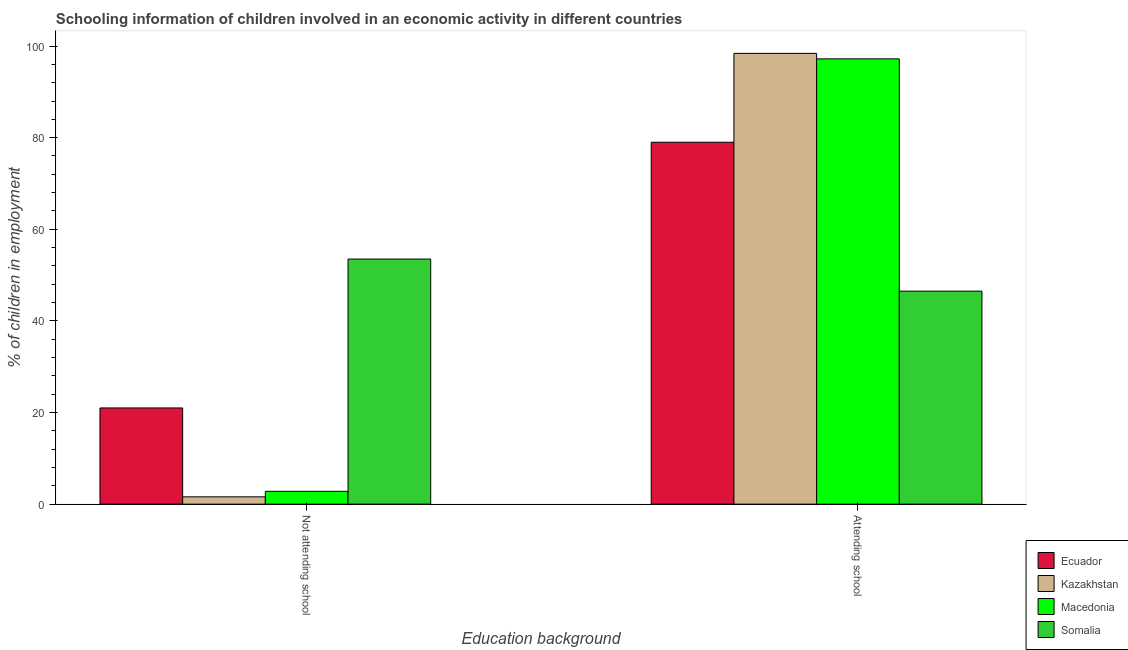Are the number of bars per tick equal to the number of legend labels?
Your response must be concise. Yes. How many bars are there on the 2nd tick from the left?
Keep it short and to the point. 4. How many bars are there on the 1st tick from the right?
Keep it short and to the point. 4. What is the label of the 2nd group of bars from the left?
Make the answer very short. Attending school. What is the percentage of employed children who are attending school in Ecuador?
Provide a succinct answer. 79. Across all countries, what is the maximum percentage of employed children who are not attending school?
Provide a succinct answer. 53.5. Across all countries, what is the minimum percentage of employed children who are attending school?
Offer a very short reply. 46.5. In which country was the percentage of employed children who are not attending school maximum?
Offer a terse response. Somalia. In which country was the percentage of employed children who are attending school minimum?
Provide a succinct answer. Somalia. What is the total percentage of employed children who are not attending school in the graph?
Your answer should be very brief. 78.9. What is the difference between the percentage of employed children who are attending school in Kazakhstan and that in Ecuador?
Offer a very short reply. 19.4. What is the difference between the percentage of employed children who are not attending school in Somalia and the percentage of employed children who are attending school in Macedonia?
Your answer should be compact. -43.7. What is the average percentage of employed children who are attending school per country?
Provide a succinct answer. 80.28. What is the ratio of the percentage of employed children who are not attending school in Kazakhstan to that in Macedonia?
Offer a very short reply. 0.57. In how many countries, is the percentage of employed children who are attending school greater than the average percentage of employed children who are attending school taken over all countries?
Offer a terse response. 2. What does the 2nd bar from the left in Attending school represents?
Give a very brief answer. Kazakhstan. What does the 1st bar from the right in Not attending school represents?
Make the answer very short. Somalia. Does the graph contain any zero values?
Provide a succinct answer. No. Does the graph contain grids?
Your answer should be compact. No. Where does the legend appear in the graph?
Provide a short and direct response. Bottom right. How are the legend labels stacked?
Your answer should be compact. Vertical. What is the title of the graph?
Make the answer very short. Schooling information of children involved in an economic activity in different countries. What is the label or title of the X-axis?
Keep it short and to the point. Education background. What is the label or title of the Y-axis?
Ensure brevity in your answer.  % of children in employment. What is the % of children in employment of Kazakhstan in Not attending school?
Provide a succinct answer. 1.6. What is the % of children in employment of Macedonia in Not attending school?
Offer a very short reply. 2.8. What is the % of children in employment of Somalia in Not attending school?
Offer a terse response. 53.5. What is the % of children in employment in Ecuador in Attending school?
Provide a succinct answer. 79. What is the % of children in employment of Kazakhstan in Attending school?
Keep it short and to the point. 98.4. What is the % of children in employment of Macedonia in Attending school?
Keep it short and to the point. 97.2. What is the % of children in employment of Somalia in Attending school?
Offer a very short reply. 46.5. Across all Education background, what is the maximum % of children in employment in Ecuador?
Provide a short and direct response. 79. Across all Education background, what is the maximum % of children in employment in Kazakhstan?
Your response must be concise. 98.4. Across all Education background, what is the maximum % of children in employment in Macedonia?
Your answer should be compact. 97.2. Across all Education background, what is the maximum % of children in employment in Somalia?
Your answer should be compact. 53.5. Across all Education background, what is the minimum % of children in employment in Kazakhstan?
Your answer should be compact. 1.6. Across all Education background, what is the minimum % of children in employment in Macedonia?
Offer a terse response. 2.8. Across all Education background, what is the minimum % of children in employment of Somalia?
Your answer should be compact. 46.5. What is the total % of children in employment in Macedonia in the graph?
Provide a short and direct response. 100. What is the total % of children in employment in Somalia in the graph?
Your response must be concise. 100. What is the difference between the % of children in employment of Ecuador in Not attending school and that in Attending school?
Your answer should be very brief. -58. What is the difference between the % of children in employment in Kazakhstan in Not attending school and that in Attending school?
Offer a very short reply. -96.8. What is the difference between the % of children in employment in Macedonia in Not attending school and that in Attending school?
Your answer should be very brief. -94.4. What is the difference between the % of children in employment of Ecuador in Not attending school and the % of children in employment of Kazakhstan in Attending school?
Your answer should be very brief. -77.4. What is the difference between the % of children in employment in Ecuador in Not attending school and the % of children in employment in Macedonia in Attending school?
Give a very brief answer. -76.2. What is the difference between the % of children in employment in Ecuador in Not attending school and the % of children in employment in Somalia in Attending school?
Your answer should be compact. -25.5. What is the difference between the % of children in employment in Kazakhstan in Not attending school and the % of children in employment in Macedonia in Attending school?
Keep it short and to the point. -95.6. What is the difference between the % of children in employment of Kazakhstan in Not attending school and the % of children in employment of Somalia in Attending school?
Offer a terse response. -44.9. What is the difference between the % of children in employment in Macedonia in Not attending school and the % of children in employment in Somalia in Attending school?
Provide a short and direct response. -43.7. What is the average % of children in employment of Kazakhstan per Education background?
Your response must be concise. 50. What is the average % of children in employment in Macedonia per Education background?
Your answer should be compact. 50. What is the difference between the % of children in employment of Ecuador and % of children in employment of Somalia in Not attending school?
Give a very brief answer. -32.5. What is the difference between the % of children in employment of Kazakhstan and % of children in employment of Macedonia in Not attending school?
Make the answer very short. -1.2. What is the difference between the % of children in employment of Kazakhstan and % of children in employment of Somalia in Not attending school?
Ensure brevity in your answer.  -51.9. What is the difference between the % of children in employment in Macedonia and % of children in employment in Somalia in Not attending school?
Offer a very short reply. -50.7. What is the difference between the % of children in employment in Ecuador and % of children in employment in Kazakhstan in Attending school?
Give a very brief answer. -19.4. What is the difference between the % of children in employment in Ecuador and % of children in employment in Macedonia in Attending school?
Provide a succinct answer. -18.2. What is the difference between the % of children in employment of Ecuador and % of children in employment of Somalia in Attending school?
Your answer should be compact. 32.5. What is the difference between the % of children in employment in Kazakhstan and % of children in employment in Somalia in Attending school?
Make the answer very short. 51.9. What is the difference between the % of children in employment of Macedonia and % of children in employment of Somalia in Attending school?
Offer a very short reply. 50.7. What is the ratio of the % of children in employment of Ecuador in Not attending school to that in Attending school?
Ensure brevity in your answer.  0.27. What is the ratio of the % of children in employment in Kazakhstan in Not attending school to that in Attending school?
Your answer should be very brief. 0.02. What is the ratio of the % of children in employment of Macedonia in Not attending school to that in Attending school?
Your answer should be very brief. 0.03. What is the ratio of the % of children in employment in Somalia in Not attending school to that in Attending school?
Your answer should be compact. 1.15. What is the difference between the highest and the second highest % of children in employment in Ecuador?
Provide a succinct answer. 58. What is the difference between the highest and the second highest % of children in employment in Kazakhstan?
Make the answer very short. 96.8. What is the difference between the highest and the second highest % of children in employment of Macedonia?
Provide a succinct answer. 94.4. What is the difference between the highest and the lowest % of children in employment of Ecuador?
Ensure brevity in your answer.  58. What is the difference between the highest and the lowest % of children in employment in Kazakhstan?
Provide a succinct answer. 96.8. What is the difference between the highest and the lowest % of children in employment of Macedonia?
Keep it short and to the point. 94.4. 